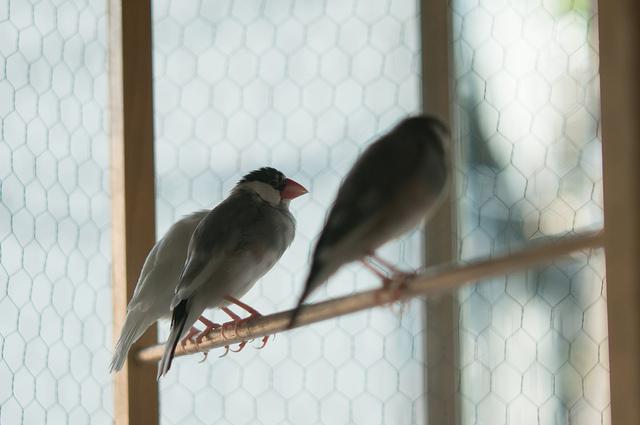How many birds are there?
Be succinct. 3. What kind of birds are they?
Write a very short answer. Small. What are the birds sitting on?
Keep it brief. Perch. 